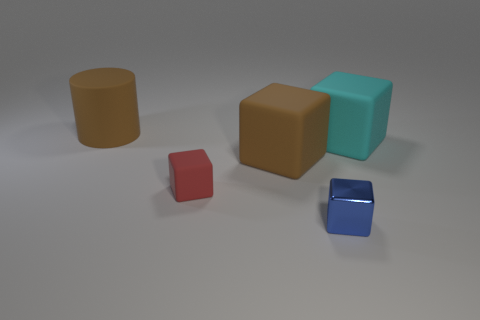Add 1 small green rubber cylinders. How many objects exist? 6 Subtract all red cubes. How many cubes are left? 3 Subtract all brown cubes. How many cubes are left? 3 Subtract all cylinders. Subtract all large green shiny cubes. How many objects are left? 4 Add 2 cyan rubber things. How many cyan rubber things are left? 3 Add 4 large brown cylinders. How many large brown cylinders exist? 5 Subtract 0 purple cylinders. How many objects are left? 5 Subtract all blocks. How many objects are left? 1 Subtract all yellow blocks. Subtract all yellow balls. How many blocks are left? 4 